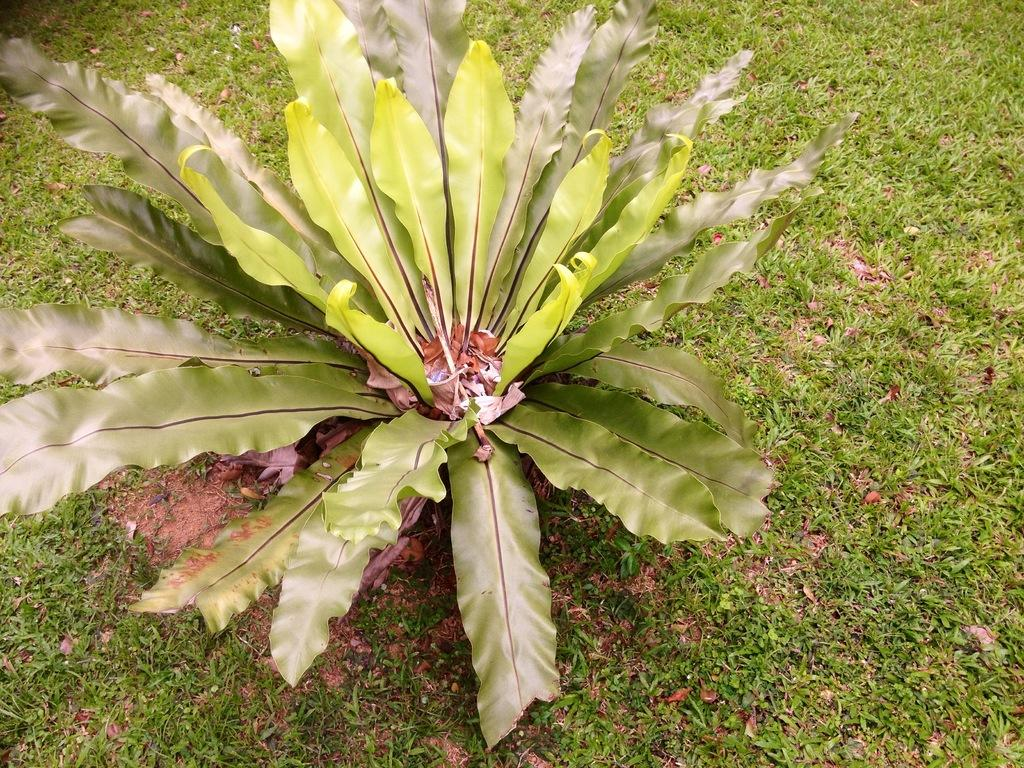What type of vegetation can be seen in the image? There is grass in the image. Is there anything else visible in front of the grass? Yes, there is a plant in front of the grass. What type of mask is the grass wearing in the image? There is no mask present in the image, as the subject is grass and not a person or animal. 